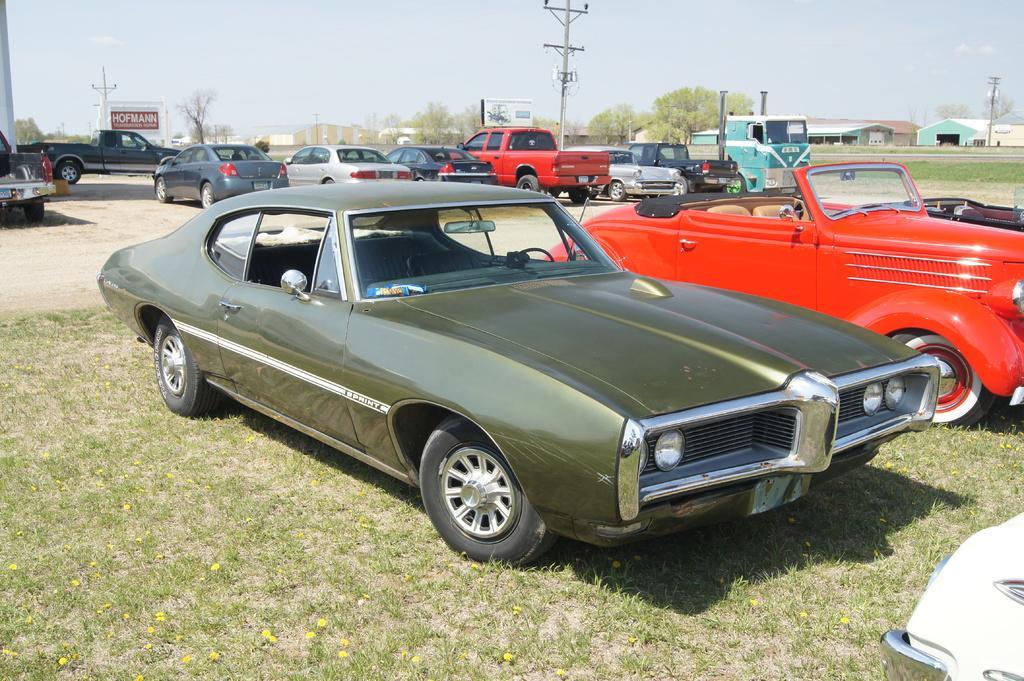In one or two sentences, can you explain what this image depicts? In the picture there are plenty of different types of cars are parked on the ground and at a distance from the ground there are some compartments, behind the cars there are few current poles and in the background there are many trees. 